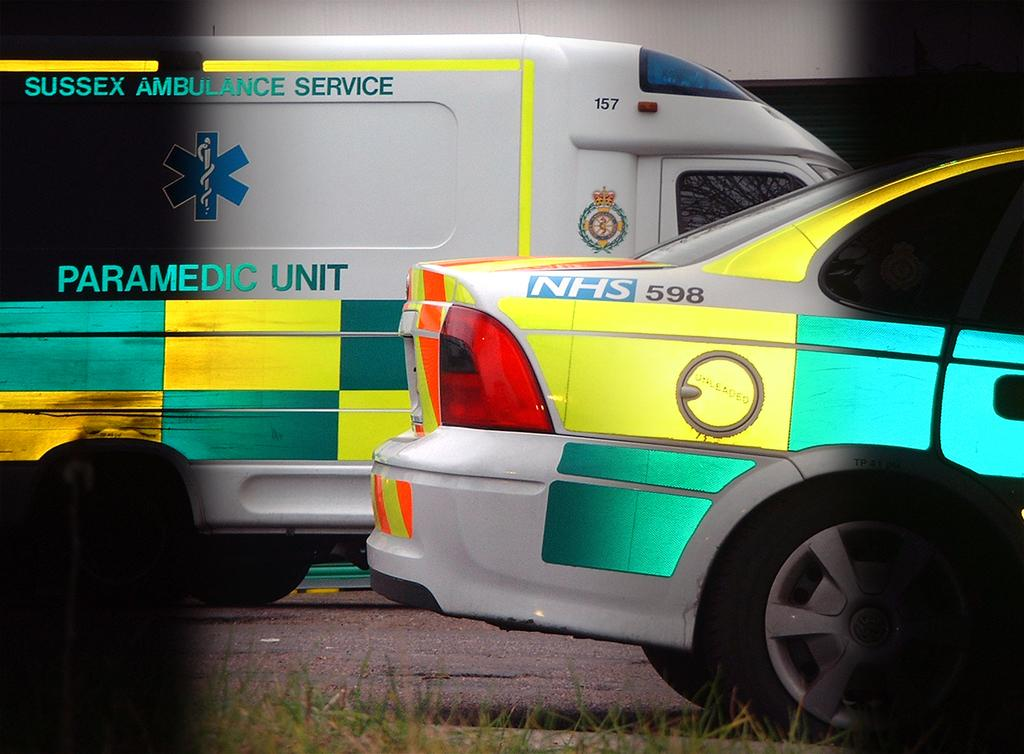<image>
Present a compact description of the photo's key features. The Sussex Ambulance Service has ambulances with colorful green and yellow sides. 